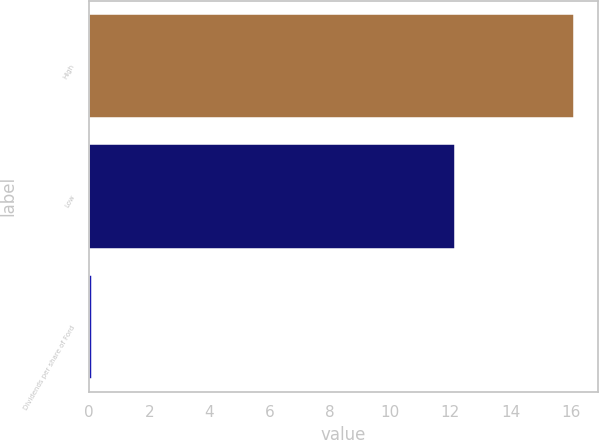Convert chart to OTSL. <chart><loc_0><loc_0><loc_500><loc_500><bar_chart><fcel>High<fcel>Low<fcel>Dividends per share of Ford<nl><fcel>16.09<fcel>12.15<fcel>0.1<nl></chart> 